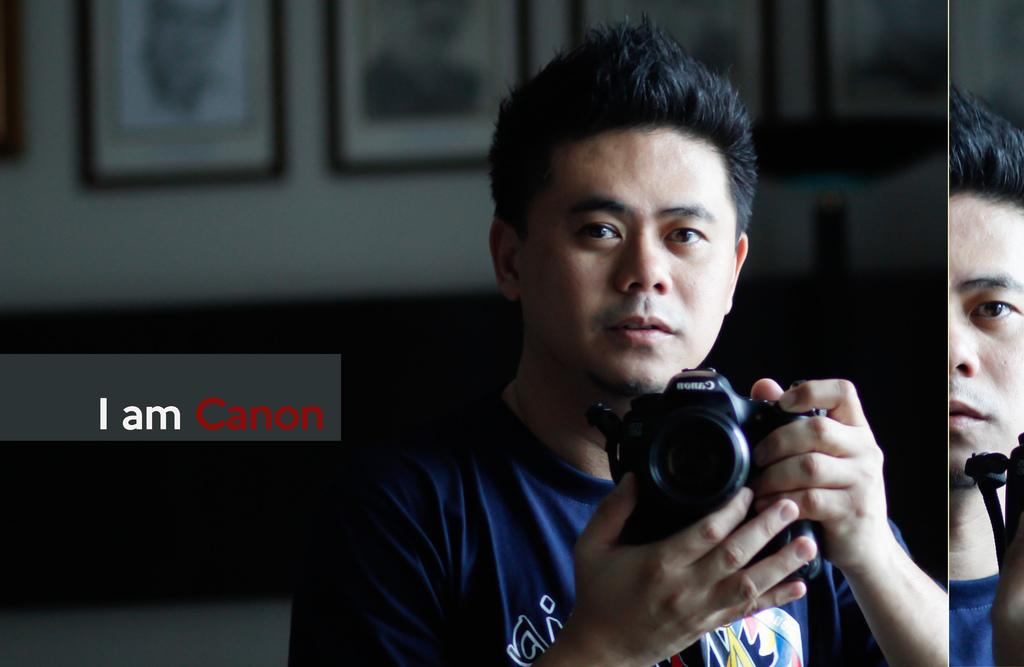What can be seen in the image? There is a person in the image. What is the person wearing? The person is wearing a blue T-shirt. What is the person holding in his hand? The person is holding a camera in his hand. What text is written at the left side of the image? The text "I'am canon" is written at the left side of the image. What type of mark is visible on the person's forehead in the image? There is no mark visible on the person's forehead in the image. What knowledge does the person possess about photography in the image? The image does not provide any information about the person's knowledge of photography. 